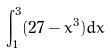Convert formula to latex. <formula><loc_0><loc_0><loc_500><loc_500>\int _ { 1 } ^ { 3 } ( 2 7 - x ^ { 3 } ) d x</formula> 